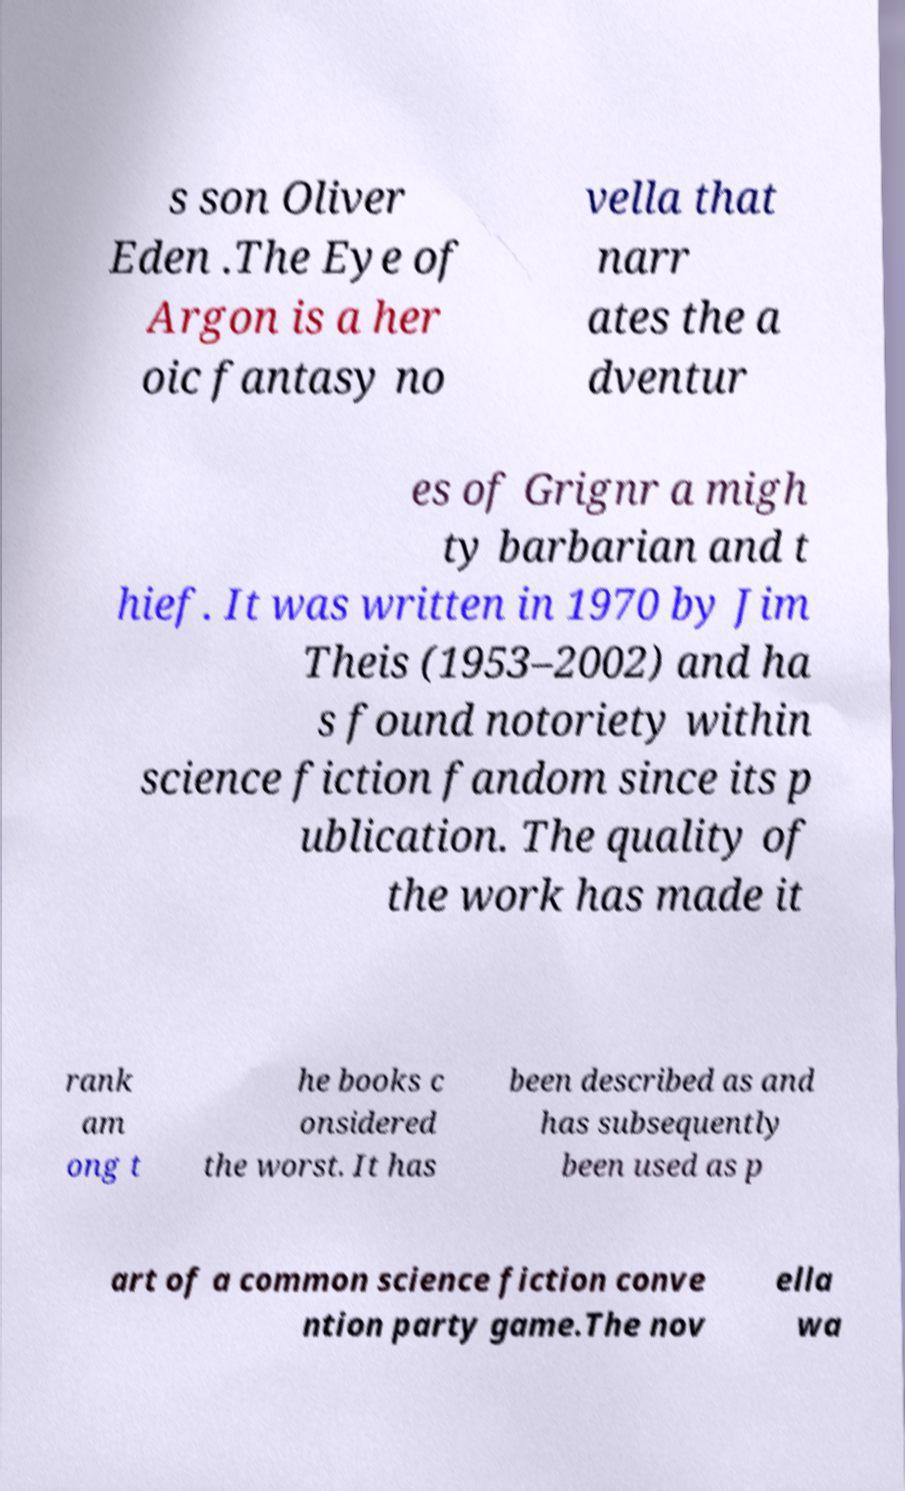Please read and relay the text visible in this image. What does it say? s son Oliver Eden .The Eye of Argon is a her oic fantasy no vella that narr ates the a dventur es of Grignr a migh ty barbarian and t hief. It was written in 1970 by Jim Theis (1953–2002) and ha s found notoriety within science fiction fandom since its p ublication. The quality of the work has made it rank am ong t he books c onsidered the worst. It has been described as and has subsequently been used as p art of a common science fiction conve ntion party game.The nov ella wa 